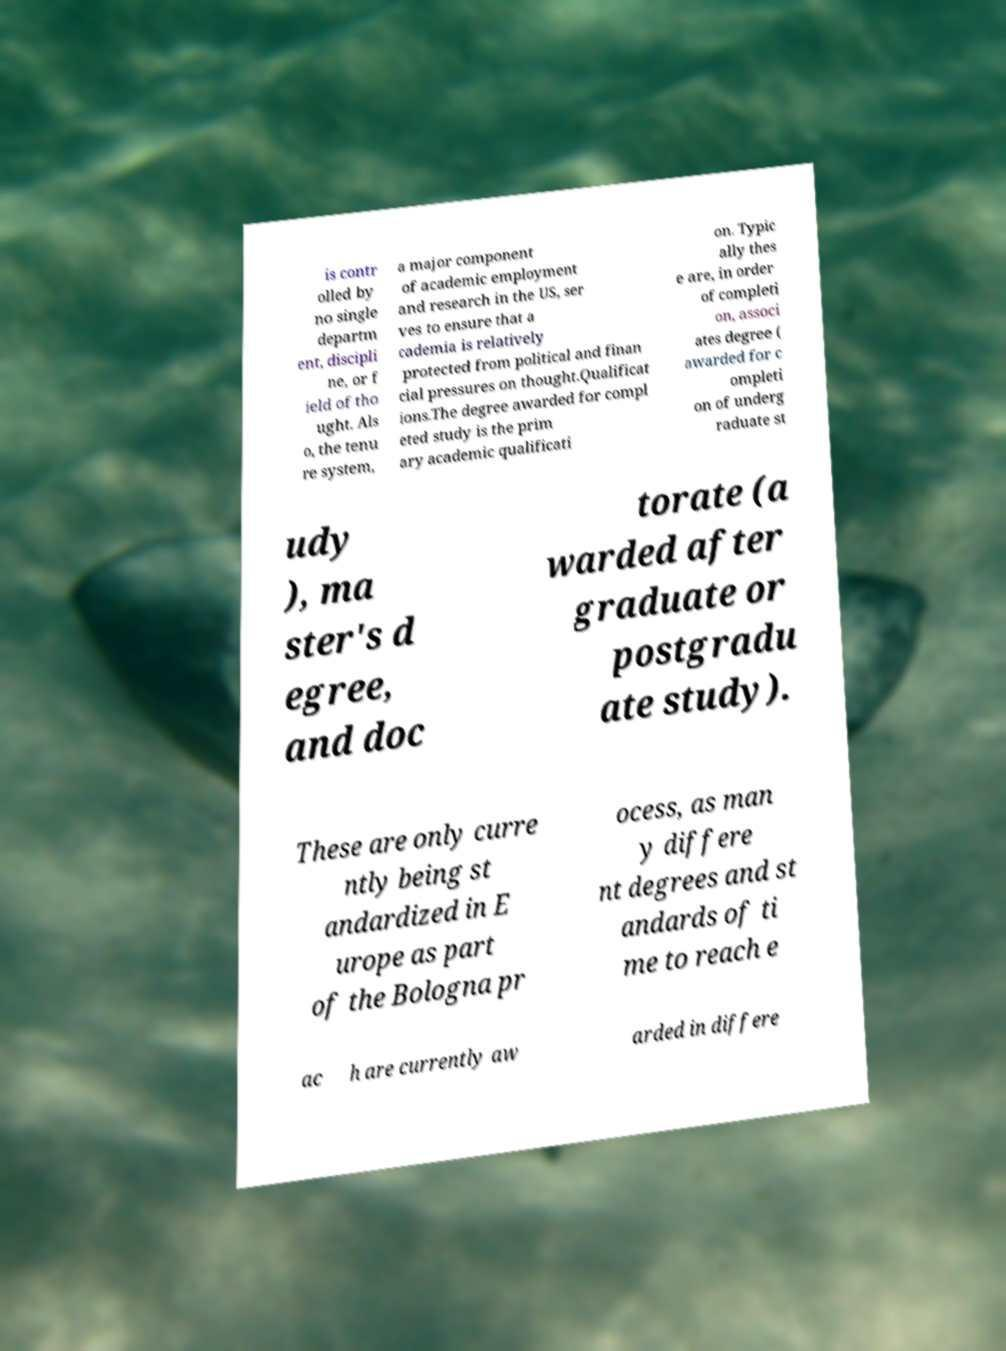Please read and relay the text visible in this image. What does it say? is contr olled by no single departm ent, discipli ne, or f ield of tho ught. Als o, the tenu re system, a major component of academic employment and research in the US, ser ves to ensure that a cademia is relatively protected from political and finan cial pressures on thought.Qualificat ions.The degree awarded for compl eted study is the prim ary academic qualificati on. Typic ally thes e are, in order of completi on, associ ates degree ( awarded for c ompleti on of underg raduate st udy ), ma ster's d egree, and doc torate (a warded after graduate or postgradu ate study). These are only curre ntly being st andardized in E urope as part of the Bologna pr ocess, as man y differe nt degrees and st andards of ti me to reach e ac h are currently aw arded in differe 